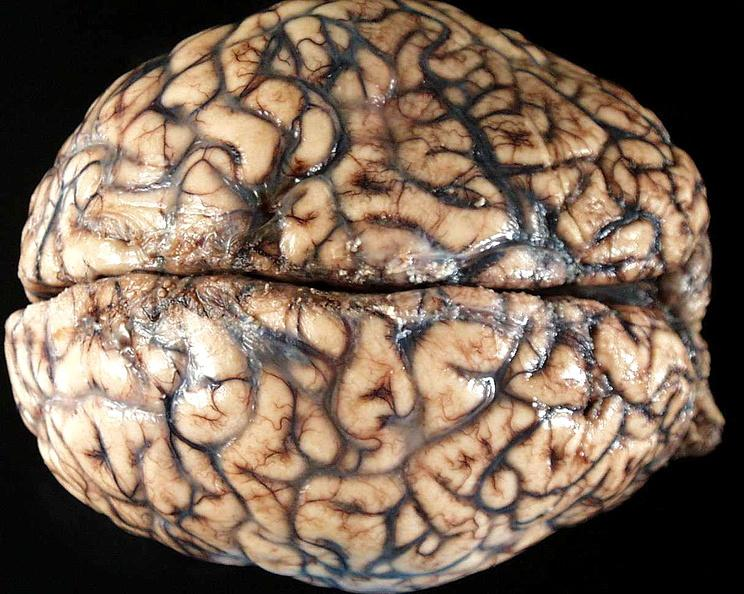what is present?
Answer the question using a single word or phrase. Nervous 